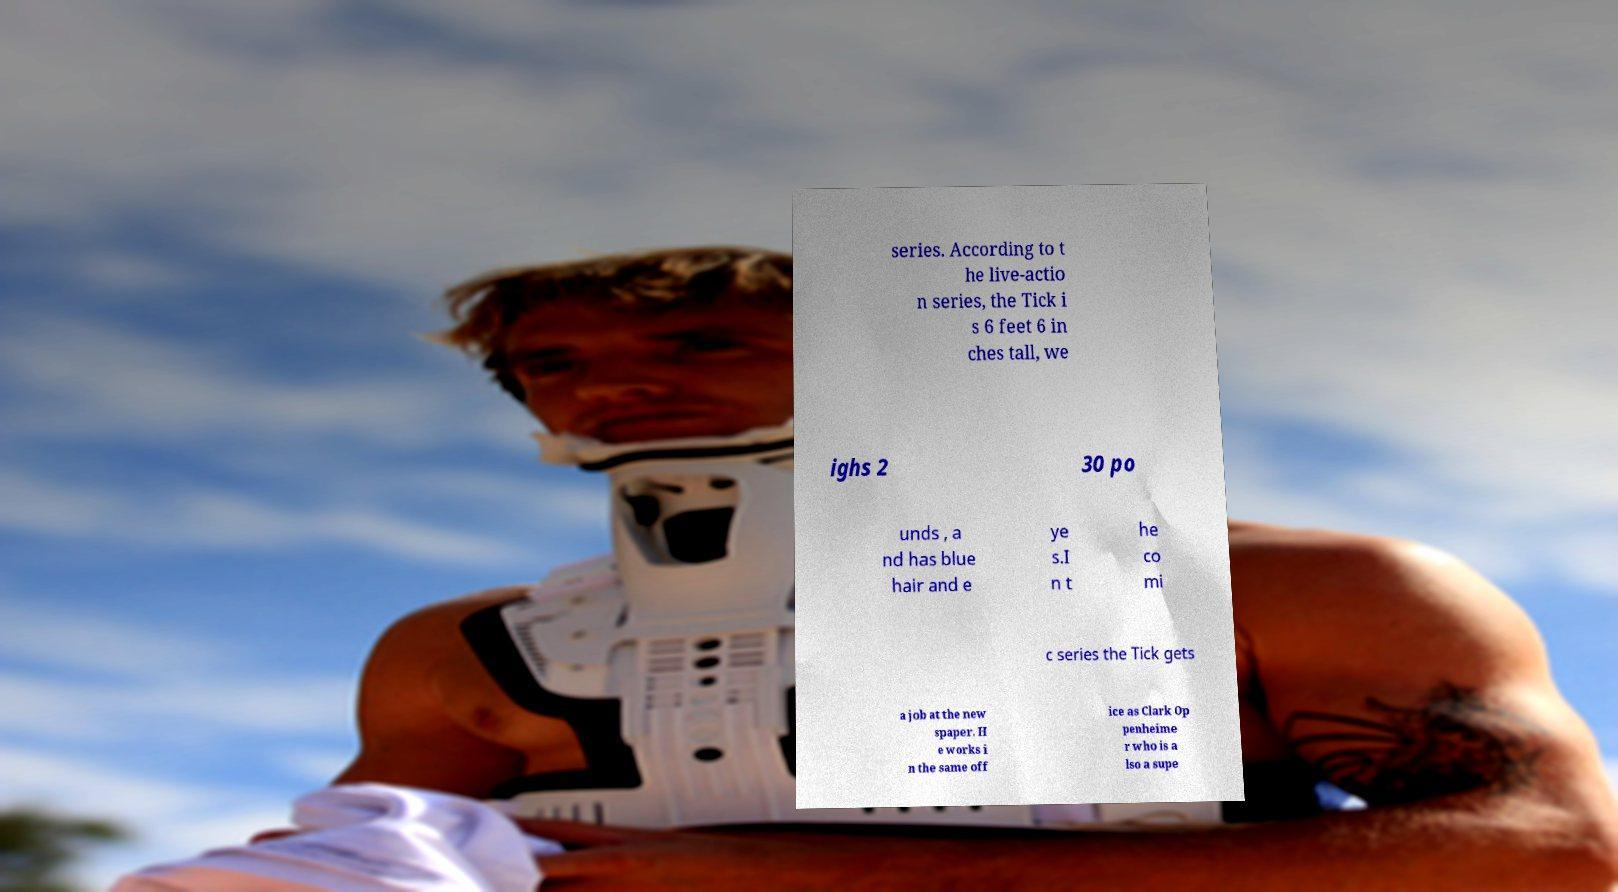I need the written content from this picture converted into text. Can you do that? series. According to t he live-actio n series, the Tick i s 6 feet 6 in ches tall, we ighs 2 30 po unds , a nd has blue hair and e ye s.I n t he co mi c series the Tick gets a job at the new spaper. H e works i n the same off ice as Clark Op penheime r who is a lso a supe 